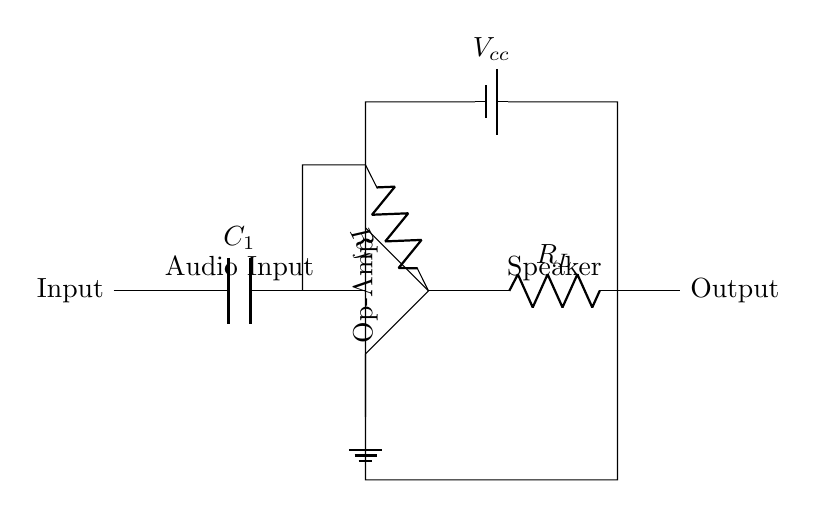What is the type of the main amplifier used in this circuit? The main amplifier in this circuit is indicated by the label "Op-Amp", which is a common type of operational amplifier used for amplifying signals.
Answer: Op-Amp What is the function of capacitor C1 in the circuit? Capacitor C1 is used to couple the audio input to the amplifier, allowing AC signals (like audio) to pass while blocking DC components, which can prevent offset issues.
Answer: Coupling What is the value of the feedback resistor? The feedback resistor is labeled as Rf, but no specific numerical value is given in the circuit diagram. Hence, we cannot determine a specific value.
Answer: Rf How many power supply connections can be identified? There is one battery labeled as "Vcc" which supplies power to the op-amp, indicating a single supply connection in this circuit.
Answer: One What is the load resistor value denoted in the output section? The load resistor is labeled as "R_L", but like R_f, it does not have a specific value provided in the circuit diagram.
Answer: R_L What is the output connection of the amplifier linked to? The output of the amplifier, indicated by the connection point to "Output", is connected to the load resistor R_L, which typically drives the speaker load in audio applications.
Answer: Load resistor What type of components connect the input to the amplifier? The input to the amplifier is connected through a capacitor, indicated by C1, which allows for AC signals to be transmitted while blocking DC.
Answer: Capacitor 